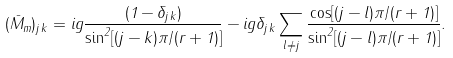<formula> <loc_0><loc_0><loc_500><loc_500>( \bar { M } _ { m } ) _ { j \, k } = i g { \frac { ( 1 - \delta _ { j \, k } ) } { \sin ^ { 2 } [ ( j - k ) \pi / ( r + 1 ) ] } } - i g \delta _ { j \, k } \sum _ { l \ne j } { \frac { \cos [ ( j - l ) \pi / ( r + 1 ) ] } { \sin ^ { 2 } [ ( j - l ) \pi / ( r + 1 ) ] } } .</formula> 